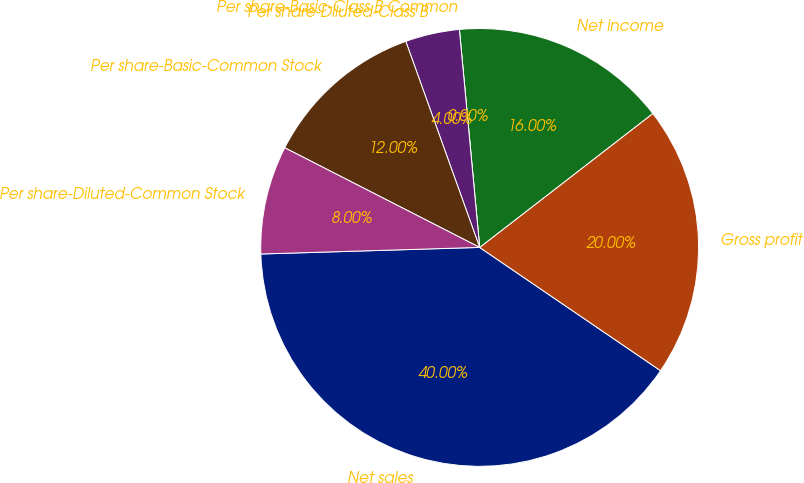<chart> <loc_0><loc_0><loc_500><loc_500><pie_chart><fcel>Net sales<fcel>Gross profit<fcel>Net income<fcel>Per share-Basic-Class B Common<fcel>Per share-Diluted-Class B<fcel>Per share-Basic-Common Stock<fcel>Per share-Diluted-Common Stock<nl><fcel>40.0%<fcel>20.0%<fcel>16.0%<fcel>0.0%<fcel>4.0%<fcel>12.0%<fcel>8.0%<nl></chart> 